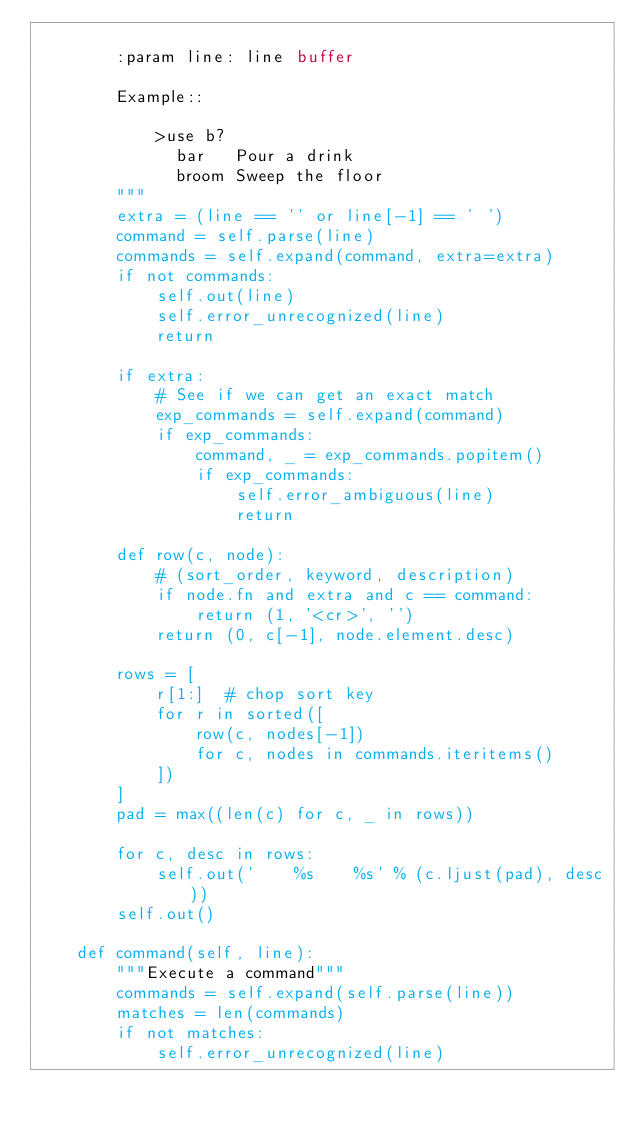Convert code to text. <code><loc_0><loc_0><loc_500><loc_500><_Python_>
        :param line: line buffer

        Example::

            >use b?
              bar   Pour a drink
              broom Sweep the floor
        """
        extra = (line == '' or line[-1] == ' ')
        command = self.parse(line)
        commands = self.expand(command, extra=extra)
        if not commands:
            self.out(line)
            self.error_unrecognized(line)
            return

        if extra:
            # See if we can get an exact match
            exp_commands = self.expand(command)
            if exp_commands:
                command, _ = exp_commands.popitem()
                if exp_commands:
                    self.error_ambiguous(line)
                    return

        def row(c, node):
            # (sort_order, keyword, description)
            if node.fn and extra and c == command:
                return (1, '<cr>', '')
            return (0, c[-1], node.element.desc)

        rows = [
            r[1:]  # chop sort key
            for r in sorted([
                row(c, nodes[-1])
                for c, nodes in commands.iteritems()
            ])
        ]
        pad = max((len(c) for c, _ in rows))

        for c, desc in rows:
            self.out('    %s    %s' % (c.ljust(pad), desc))
        self.out()

    def command(self, line):
        """Execute a command"""
        commands = self.expand(self.parse(line))
        matches = len(commands)
        if not matches:
            self.error_unrecognized(line)</code> 